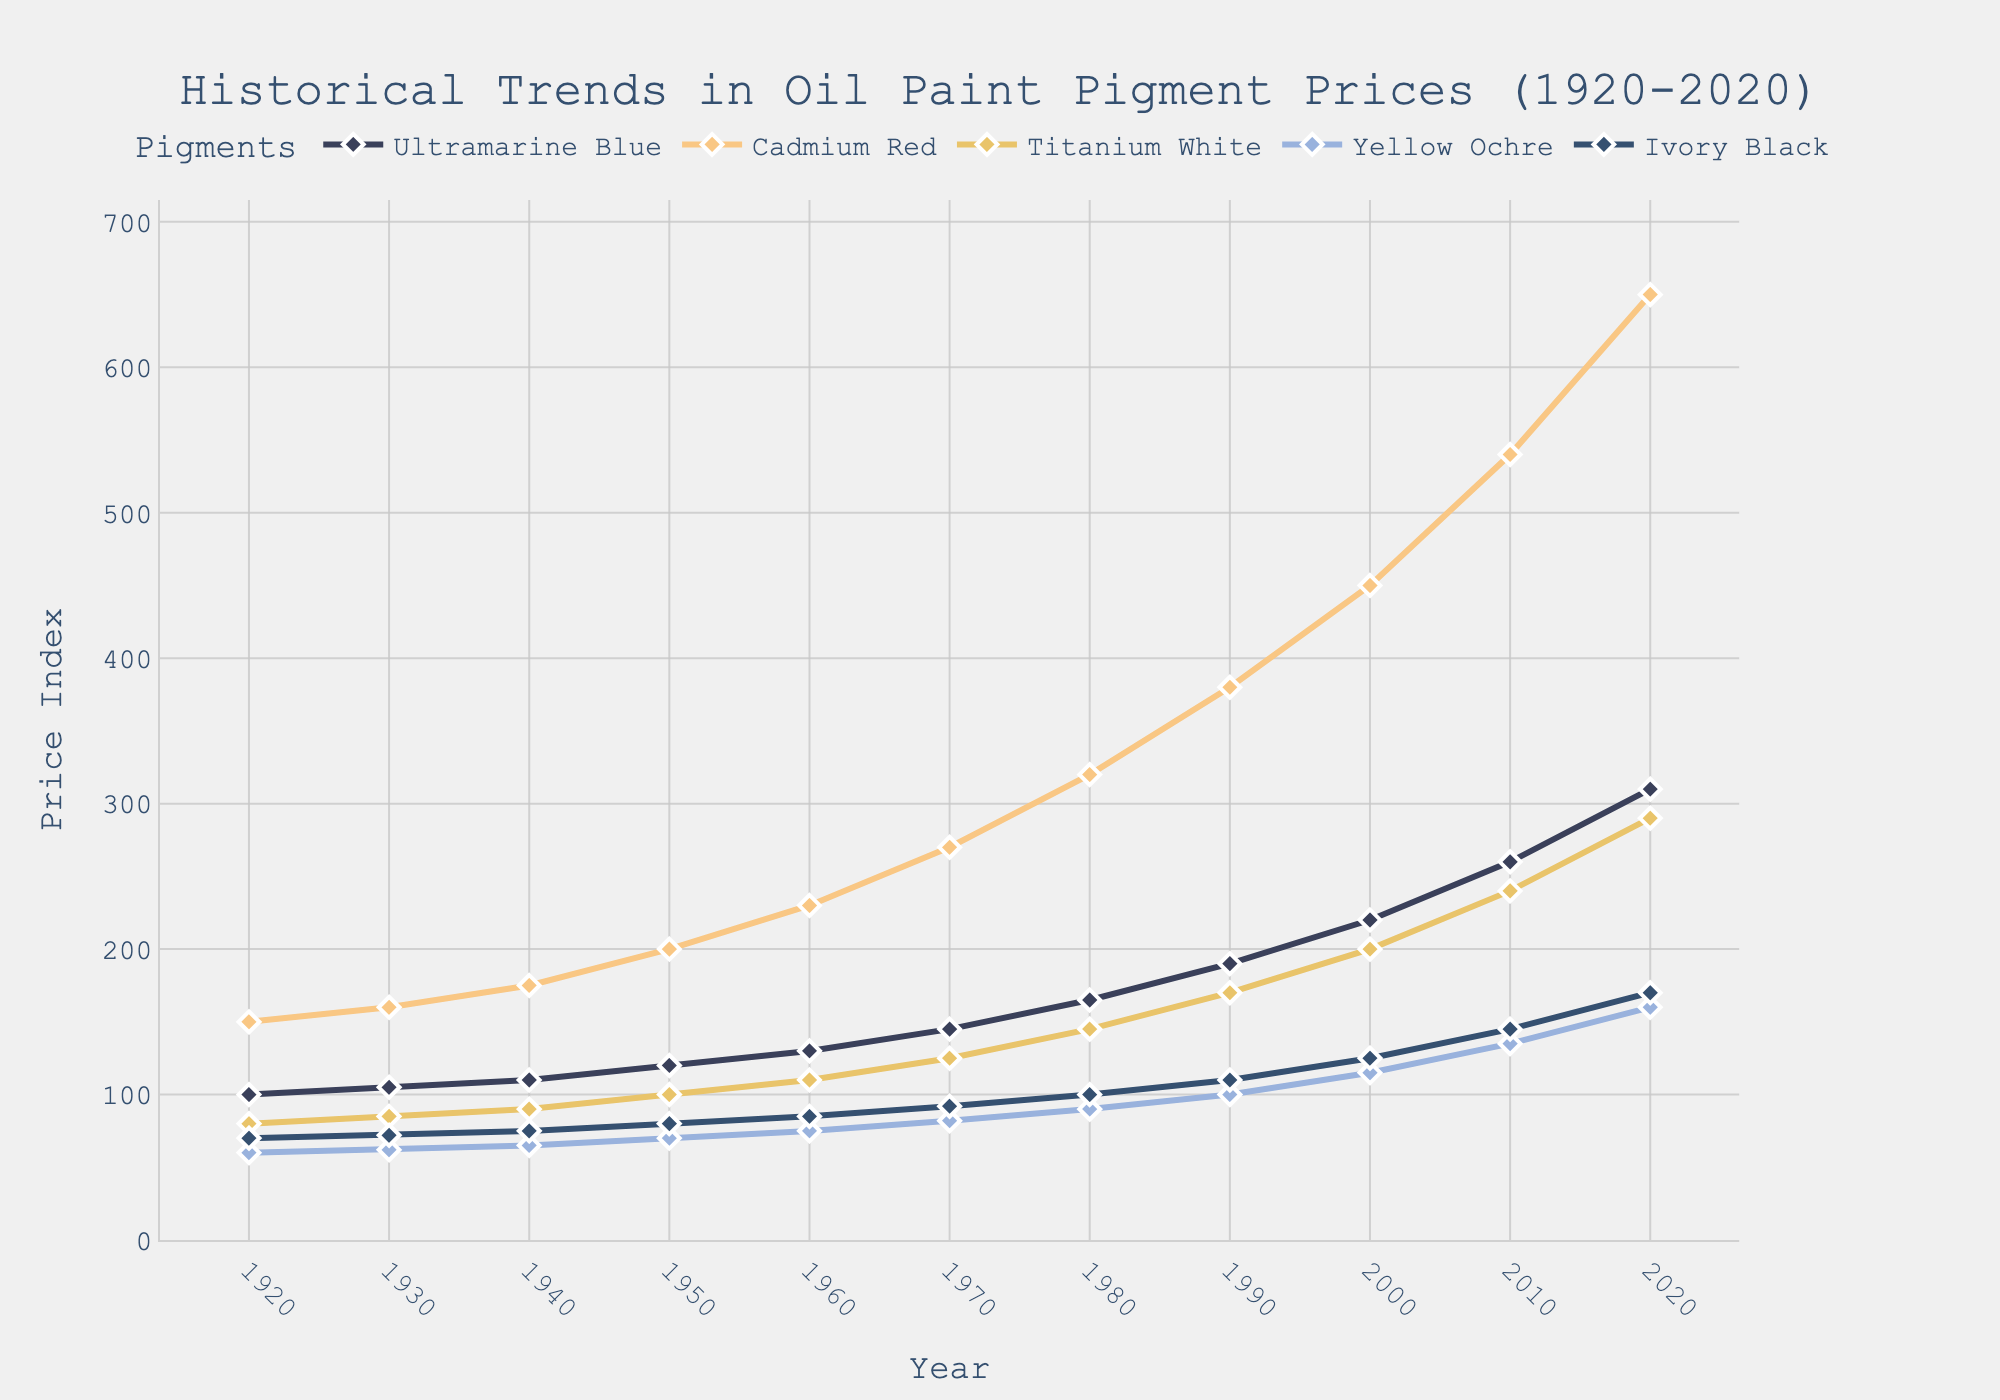What's the price increase of Cadmium Red from 1920 to 2020? The price of Cadmium Red in 1920 was 150, and in 2020 it is 650. The increase is calculated as 650 - 150 = 500
Answer: 500 Which pigment had the highest price in 2020? By looking at the data points for the year 2020, Cadmium Red stands out as the highest price with a value of 650
Answer: Cadmium Red Which pigment showed the least price increase from 1920 to 2020? For Ultramarine Blue, the increase is 310 - 100 = 210. For Cadmium Red, it’s 650 - 150 = 500. For Titanium White, it’s 290 - 80 = 210. For Yellow Ochre, it’s 160 - 60 = 100. For Ivory Black, it’s 170 - 70 = 100. Yellow Ochre and Ivory Black both have the smallest increase which is 100
Answer: Yellow Ochre and Ivory Black What's the average price of Titanium White from 1920 to 2020? The prices of Titanium White are [80, 85, 90, 100, 110, 125, 145, 170, 200, 240, 290]. Adding them gives 1635, and there are 11 points. So, the average is 1635 / 11 = 148.64
Answer: 148.64 Which pigment prices crossed the 200 mark first? Tracking the prices across years, Cadmium Red reaches 200 in 1950, whereas the other pigments cross 200 in later years
Answer: Cadmium Red In which decade did Ultramarine Blue see the largest price jump? Observing year-to-year changes, the biggest jump for Ultramarine Blue is from 1930 (105) to 1940 (110), which is 5
Answer: 1930s How much did the price of Yellow Ochre increase from 1960 to 2020? In 1960, the price was 75 and in 2020 it is 160. Therefore, the increase is 160 - 75 = 85
Answer: 85 What is the ratio of the price of Titanium White to Ivory Black in 2020? The price of Titanium White in 2020 is 290 and that of Ivory Black is 170. The ratio is 290 / 170 = 1.71
Answer: 1.71 How many times does the price of Ultramarine Blue increase from 1920 to 2020? The price of Ultramarine Blue in 1920 was 100, and in 2020 it is 310. The price increased by a factor of 310 / 100 = 3.1
Answer: 3.1 